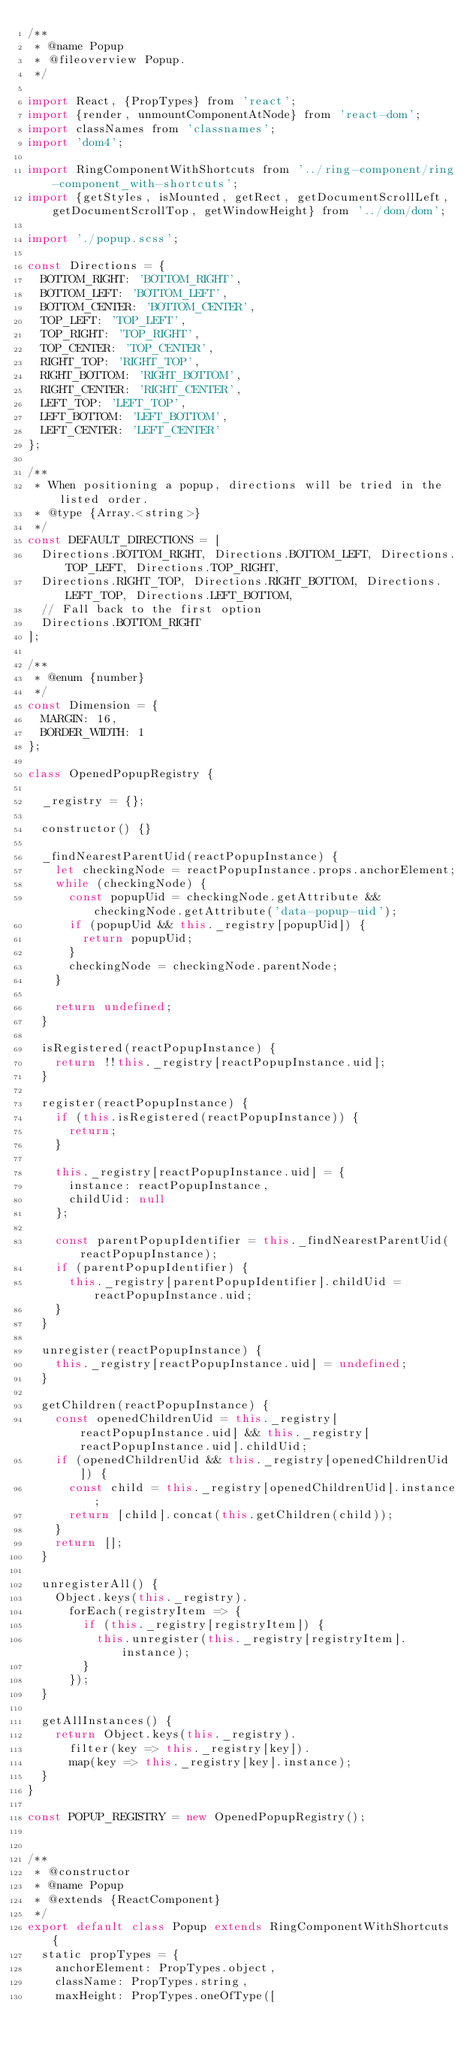<code> <loc_0><loc_0><loc_500><loc_500><_JavaScript_>/**
 * @name Popup
 * @fileoverview Popup.
 */

import React, {PropTypes} from 'react';
import {render, unmountComponentAtNode} from 'react-dom';
import classNames from 'classnames';
import 'dom4';

import RingComponentWithShortcuts from '../ring-component/ring-component_with-shortcuts';
import {getStyles, isMounted, getRect, getDocumentScrollLeft, getDocumentScrollTop, getWindowHeight} from '../dom/dom';

import './popup.scss';

const Directions = {
  BOTTOM_RIGHT: 'BOTTOM_RIGHT',
  BOTTOM_LEFT: 'BOTTOM_LEFT',
  BOTTOM_CENTER: 'BOTTOM_CENTER',
  TOP_LEFT: 'TOP_LEFT',
  TOP_RIGHT: 'TOP_RIGHT',
  TOP_CENTER: 'TOP_CENTER',
  RIGHT_TOP: 'RIGHT_TOP',
  RIGHT_BOTTOM: 'RIGHT_BOTTOM',
  RIGHT_CENTER: 'RIGHT_CENTER',
  LEFT_TOP: 'LEFT_TOP',
  LEFT_BOTTOM: 'LEFT_BOTTOM',
  LEFT_CENTER: 'LEFT_CENTER'
};

/**
 * When positioning a popup, directions will be tried in the listed order.
 * @type {Array.<string>}
 */
const DEFAULT_DIRECTIONS = [
  Directions.BOTTOM_RIGHT, Directions.BOTTOM_LEFT, Directions.TOP_LEFT, Directions.TOP_RIGHT,
  Directions.RIGHT_TOP, Directions.RIGHT_BOTTOM, Directions.LEFT_TOP, Directions.LEFT_BOTTOM,
  // Fall back to the first option
  Directions.BOTTOM_RIGHT
];

/**
 * @enum {number}
 */
const Dimension = {
  MARGIN: 16,
  BORDER_WIDTH: 1
};

class OpenedPopupRegistry {

  _registry = {};

  constructor() {}

  _findNearestParentUid(reactPopupInstance) {
    let checkingNode = reactPopupInstance.props.anchorElement;
    while (checkingNode) {
      const popupUid = checkingNode.getAttribute && checkingNode.getAttribute('data-popup-uid');
      if (popupUid && this._registry[popupUid]) {
        return popupUid;
      }
      checkingNode = checkingNode.parentNode;
    }

    return undefined;
  }

  isRegistered(reactPopupInstance) {
    return !!this._registry[reactPopupInstance.uid];
  }

  register(reactPopupInstance) {
    if (this.isRegistered(reactPopupInstance)) {
      return;
    }

    this._registry[reactPopupInstance.uid] = {
      instance: reactPopupInstance,
      childUid: null
    };

    const parentPopupIdentifier = this._findNearestParentUid(reactPopupInstance);
    if (parentPopupIdentifier) {
      this._registry[parentPopupIdentifier].childUid = reactPopupInstance.uid;
    }
  }

  unregister(reactPopupInstance) {
    this._registry[reactPopupInstance.uid] = undefined;
  }

  getChildren(reactPopupInstance) {
    const openedChildrenUid = this._registry[reactPopupInstance.uid] && this._registry[reactPopupInstance.uid].childUid;
    if (openedChildrenUid && this._registry[openedChildrenUid]) {
      const child = this._registry[openedChildrenUid].instance;
      return [child].concat(this.getChildren(child));
    }
    return [];
  }

  unregisterAll() {
    Object.keys(this._registry).
      forEach(registryItem => {
        if (this._registry[registryItem]) {
          this.unregister(this._registry[registryItem].instance);
        }
      });
  }

  getAllInstances() {
    return Object.keys(this._registry).
      filter(key => this._registry[key]).
      map(key => this._registry[key].instance);
  }
}

const POPUP_REGISTRY = new OpenedPopupRegistry();


/**
 * @constructor
 * @name Popup
 * @extends {ReactComponent}
 */
export default class Popup extends RingComponentWithShortcuts {
  static propTypes = {
    anchorElement: PropTypes.object,
    className: PropTypes.string,
    maxHeight: PropTypes.oneOfType([</code> 